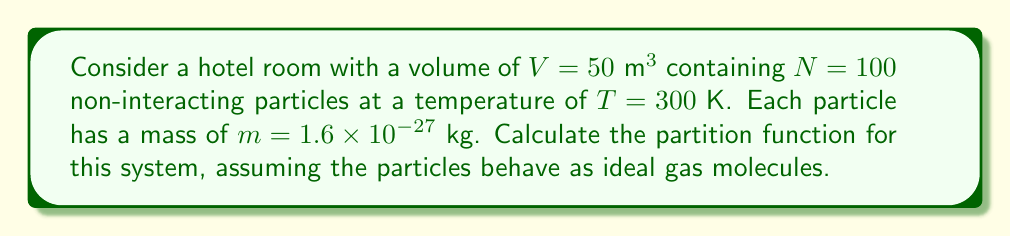Can you solve this math problem? To calculate the partition function for this system of non-interacting particles, we'll follow these steps:

1) For an ideal gas, the partition function $Z$ is given by:

   $$Z = \frac{1}{N!} \left(\frac{V}{\lambda^3}\right)^N$$

   where $\lambda$ is the thermal de Broglie wavelength.

2) The thermal de Broglie wavelength is defined as:

   $$\lambda = \frac{h}{\sqrt{2\pi mkT}}$$

   where $h$ is Planck's constant, $m$ is the mass of each particle, $k$ is Boltzmann's constant, and $T$ is the temperature.

3) Let's calculate $\lambda$:
   
   $h = 6.626 \times 10^{-34} \text{ J⋅s}$
   $k = 1.380 \times 10^{-23} \text{ J/K}$

   $$\lambda = \frac{6.626 \times 10^{-34}}{\sqrt{2\pi (1.6 \times 10^{-27})(1.380 \times 10^{-23})(300)}} = 2.527 \times 10^{-11} \text{ m}$$

4) Now we can calculate $\frac{V}{\lambda^3}$:

   $$\frac{V}{\lambda^3} = \frac{50}{(2.527 \times 10^{-11})^3} = 3.095 \times 10^{34}$$

5) Finally, we can calculate $Z$:

   $$Z = \frac{1}{100!} (3.095 \times 10^{34})^{100}$$

6) Using Stirling's approximation for large $N$: $\ln N! \approx N \ln N - N$

   $$\ln Z \approx 100 \ln(3.095 \times 10^{34}) - (100 \ln 100 - 100) = 7.913 \times 10^3$$

7) Therefore:

   $$Z \approx e^{7.913 \times 10^3} = 2.724 \times 10^{3437}$$
Answer: $Z \approx 2.724 \times 10^{3437}$ 